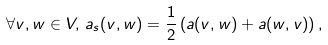<formula> <loc_0><loc_0><loc_500><loc_500>\forall v , w \in V , \, a _ { s } ( v , w ) = \frac { 1 } { 2 } \left ( a ( v , w ) + a ( w , v ) \right ) ,</formula> 